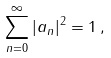<formula> <loc_0><loc_0><loc_500><loc_500>\sum _ { n = 0 } ^ { \infty } | a _ { n } | ^ { 2 } = 1 \, ,</formula> 